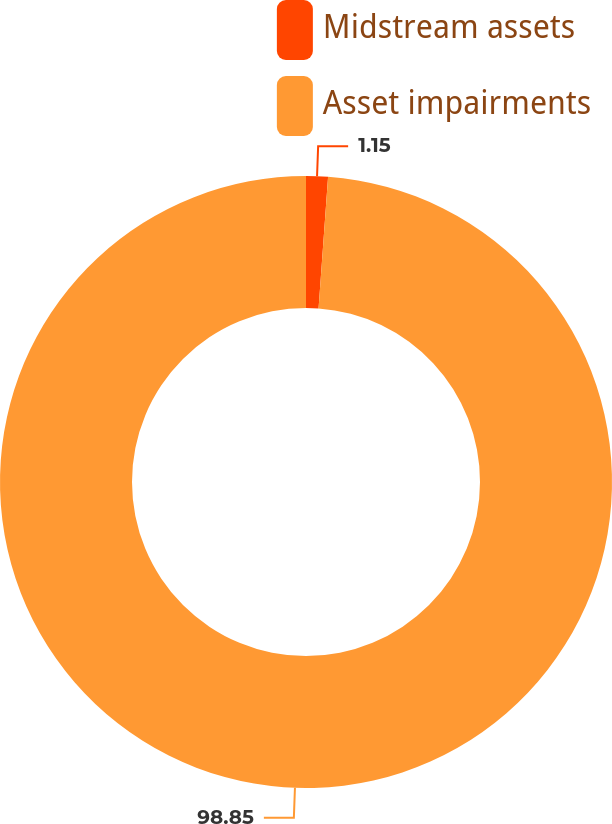<chart> <loc_0><loc_0><loc_500><loc_500><pie_chart><fcel>Midstream assets<fcel>Asset impairments<nl><fcel>1.15%<fcel>98.85%<nl></chart> 